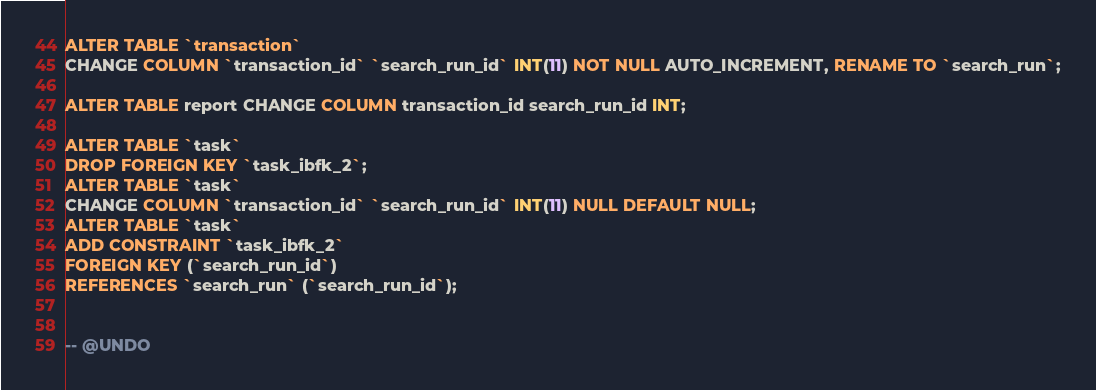Convert code to text. <code><loc_0><loc_0><loc_500><loc_500><_SQL_>ALTER TABLE `transaction`
CHANGE COLUMN `transaction_id` `search_run_id` INT(11) NOT NULL AUTO_INCREMENT, RENAME TO `search_run`;

ALTER TABLE report CHANGE COLUMN transaction_id search_run_id INT;

ALTER TABLE `task`
DROP FOREIGN KEY `task_ibfk_2`;
ALTER TABLE `task`
CHANGE COLUMN `transaction_id` `search_run_id` INT(11) NULL DEFAULT NULL;
ALTER TABLE `task`
ADD CONSTRAINT `task_ibfk_2`
FOREIGN KEY (`search_run_id`)
REFERENCES `search_run` (`search_run_id`);


-- @UNDO</code> 